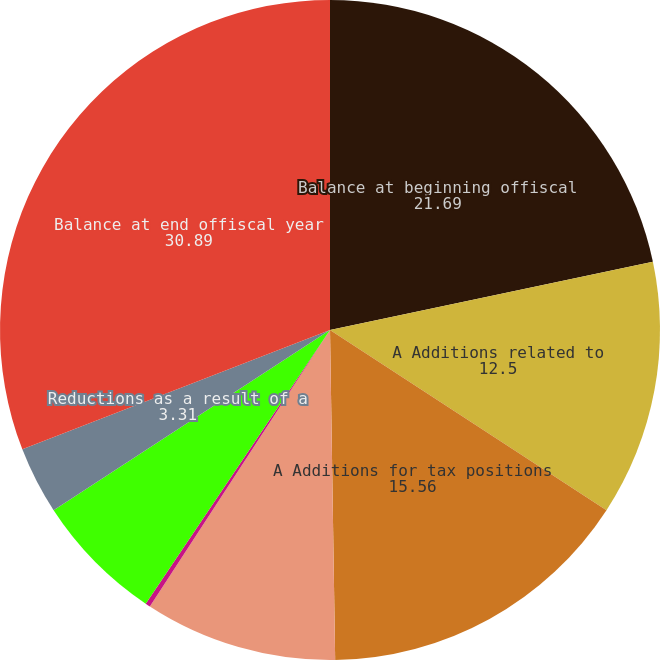<chart> <loc_0><loc_0><loc_500><loc_500><pie_chart><fcel>Balance at beginning offiscal<fcel>A Additions related to<fcel>A Additions for tax positions<fcel>Reductions for tax positions<fcel>Reductions due tosettlement<fcel>(Reductions) additions for<fcel>Reductions as a result of a<fcel>Balance at end offiscal year<nl><fcel>21.69%<fcel>12.5%<fcel>15.56%<fcel>9.44%<fcel>0.24%<fcel>6.37%<fcel>3.31%<fcel>30.89%<nl></chart> 